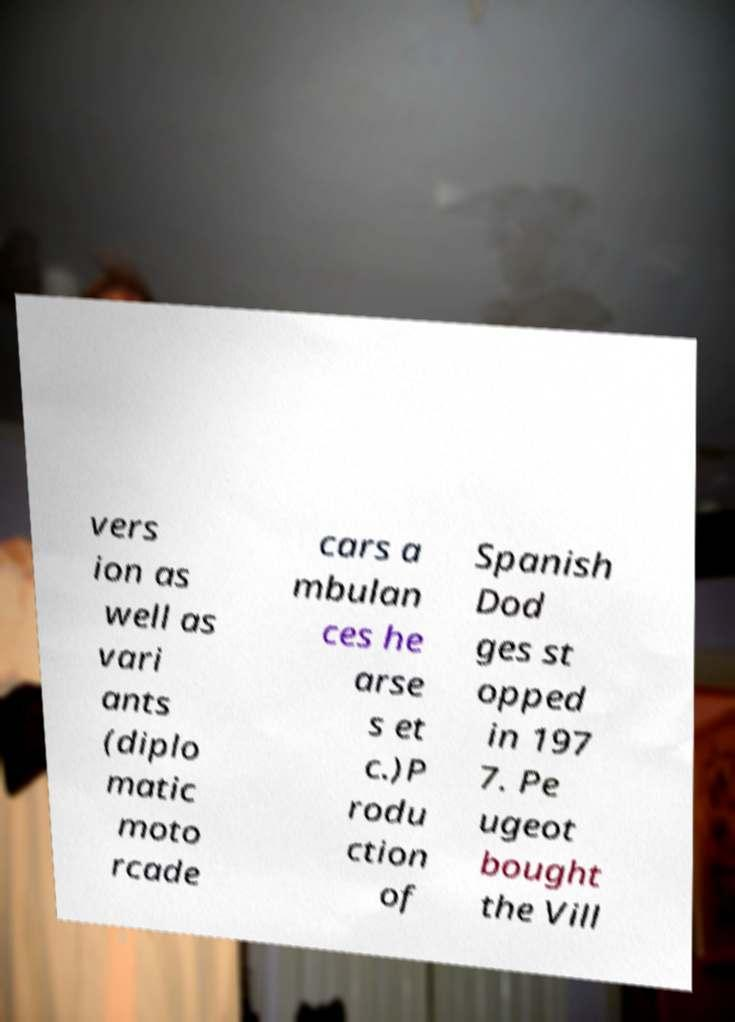Please read and relay the text visible in this image. What does it say? vers ion as well as vari ants (diplo matic moto rcade cars a mbulan ces he arse s et c.)P rodu ction of Spanish Dod ges st opped in 197 7. Pe ugeot bought the Vill 